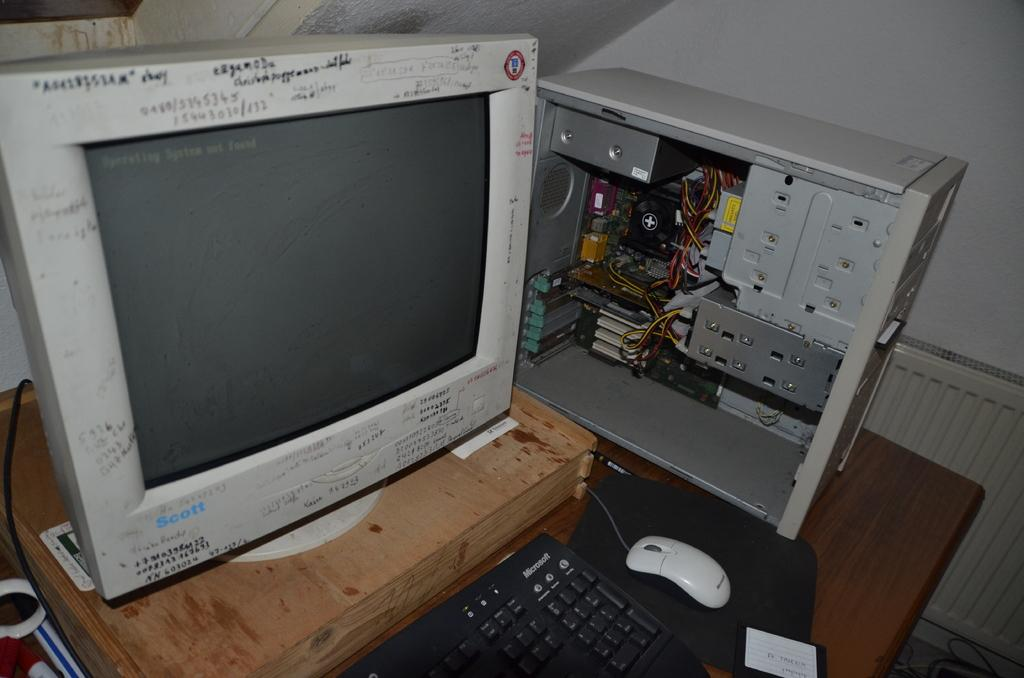<image>
Summarize the visual content of the image. A old computer sits on a table, the mouse and keyboard are made by microsoft. 